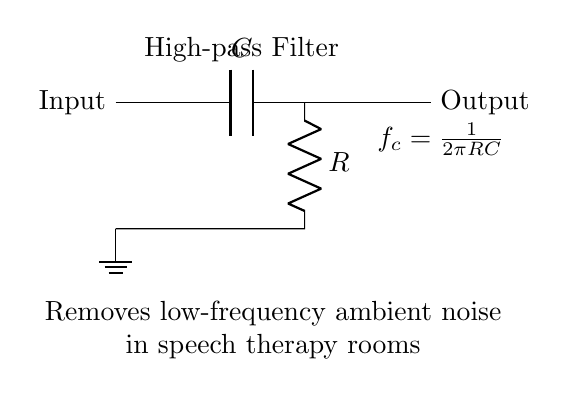What components are present in this circuit? The circuit consists of a capacitor (C) and a resistor (R), as labeled in the diagram. These components are crucial for the functionality of the high-pass filter.
Answer: Capacitor and Resistor What is the function of this circuit? This circuit is designed to remove low-frequency ambient noise, specifically in environments like speech therapy rooms. The high-pass filter allows higher frequencies to pass while attenuating lower frequencies.
Answer: Remove low-frequency noise What does the term 'cutoff frequency' refer to in this circuit? The cutoff frequency (f_c) indicates the frequency point at which the output signal starts to attenuate. It is given by the formula provided in the circuit. Frequencies below this point are significantly reduced.
Answer: Frequency point How is the cutoff frequency calculated in this high-pass filter? The cutoff frequency is calculated using the formula f_c = 1/(2πRC). This formula shows the relationship between the resistor, capacitor, and the frequency at which the filter operates.
Answer: One over two pi RC What will happen if the values of R or C are increased? Increasing R or C will lower the cutoff frequency, allowing more low-frequency signals to pass through instead of being filtered out. This alters the effectiveness of the filter in removing unwanted noise.
Answer: Cutoff frequency decreases What does the ground symbol indicate in this circuit? The ground symbol indicates the reference point for the circuit’s voltage, setting the standard potential against which other voltages in the circuit are measured. It helps complete the circuit.
Answer: Reference point 